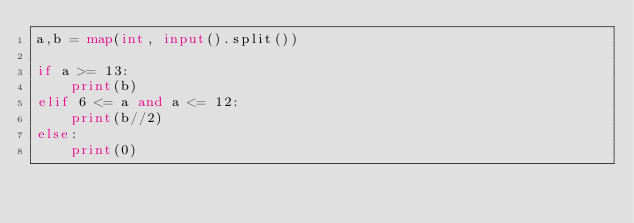Convert code to text. <code><loc_0><loc_0><loc_500><loc_500><_Python_>a,b = map(int, input().split())

if a >= 13:
    print(b)
elif 6 <= a and a <= 12:
    print(b//2)
else:
    print(0)</code> 